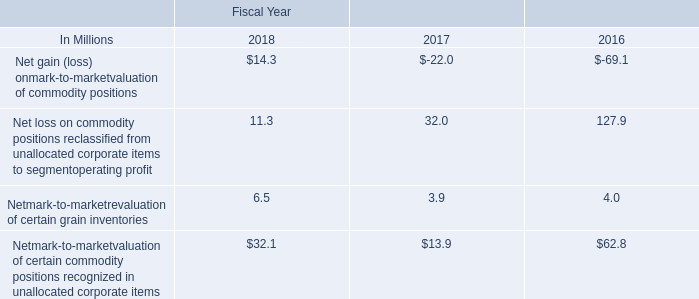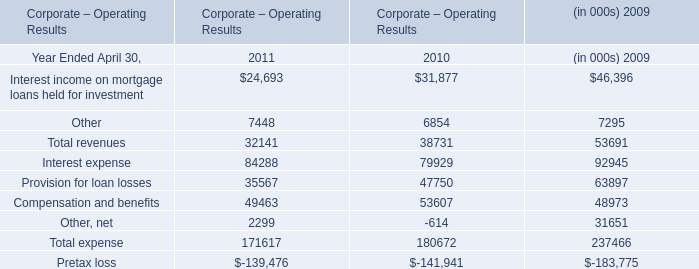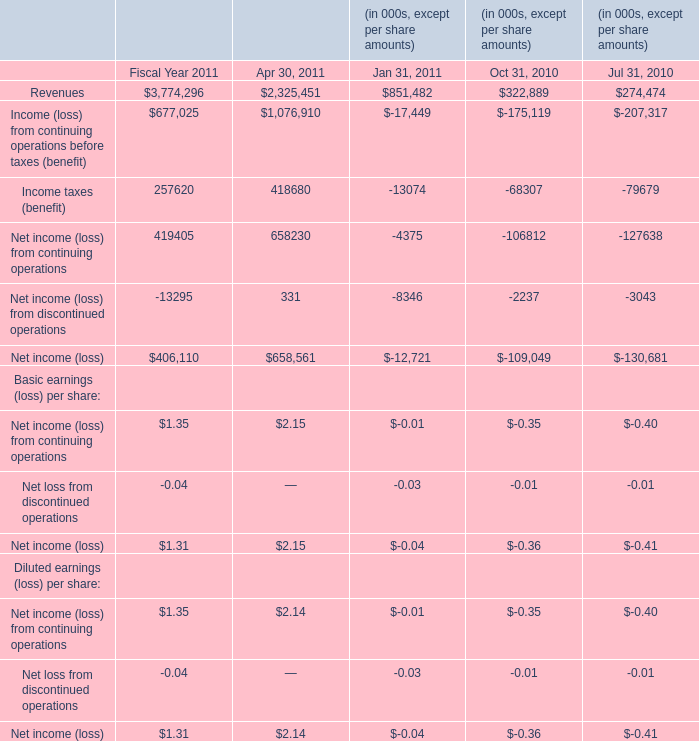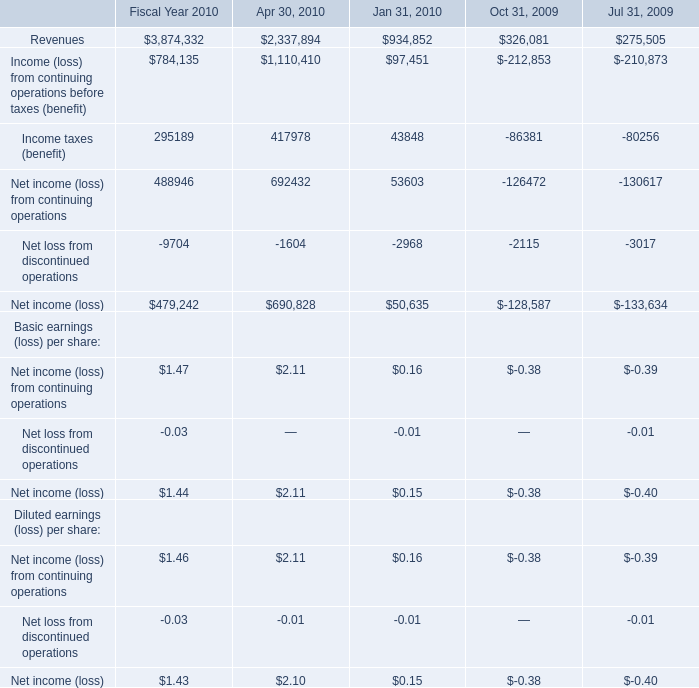What's the total amount of the Net income (loss) from discontinued operations in the years where Revenues is greater than 0? (in thousand) 
Computations: ((((-13295 + 331) - 8346) - 2237) - 3043)
Answer: -26590.0. 